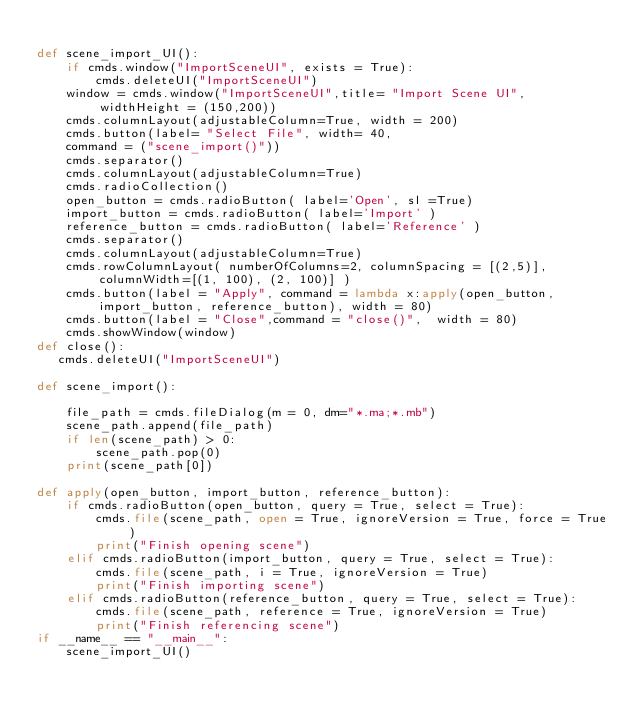Convert code to text. <code><loc_0><loc_0><loc_500><loc_500><_Python_>        
def scene_import_UI():
    if cmds.window("ImportSceneUI", exists = True):
        cmds.deleteUI("ImportSceneUI")
    window = cmds.window("ImportSceneUI",title= "Import Scene UI", widthHeight = (150,200))
    cmds.columnLayout(adjustableColumn=True, width = 200)
    cmds.button(label= "Select File", width= 40, 
    command = ("scene_import()"))
    cmds.separator()
    cmds.columnLayout(adjustableColumn=True)
    cmds.radioCollection()
    open_button = cmds.radioButton( label='Open', sl =True)
    import_button = cmds.radioButton( label='Import' )
    reference_button = cmds.radioButton( label='Reference' )
    cmds.separator()
    cmds.columnLayout(adjustableColumn=True)
    cmds.rowColumnLayout( numberOfColumns=2, columnSpacing = [(2,5)], columnWidth=[(1, 100), (2, 100)] )
    cmds.button(label = "Apply", command = lambda x:apply(open_button, import_button, reference_button), width = 80)
    cmds.button(label = "Close",command = "close()",  width = 80)  
    cmds.showWindow(window)
def close():
   cmds.deleteUI("ImportSceneUI")
    
def scene_import():

    file_path = cmds.fileDialog(m = 0, dm="*.ma;*.mb")
    scene_path.append(file_path)
    if len(scene_path) > 0:
        scene_path.pop(0)
    print(scene_path[0])
    
def apply(open_button, import_button, reference_button):
    if cmds.radioButton(open_button, query = True, select = True):
        cmds.file(scene_path, open = True, ignoreVersion = True, force = True)
        print("Finish opening scene")
    elif cmds.radioButton(import_button, query = True, select = True):
        cmds.file(scene_path, i = True, ignoreVersion = True)
        print("Finish importing scene")
    elif cmds.radioButton(reference_button, query = True, select = True):
        cmds.file(scene_path, reference = True, ignoreVersion = True)
        print("Finish referencing scene")
if __name__ == "__main__":
    scene_import_UI()
    
    
</code> 